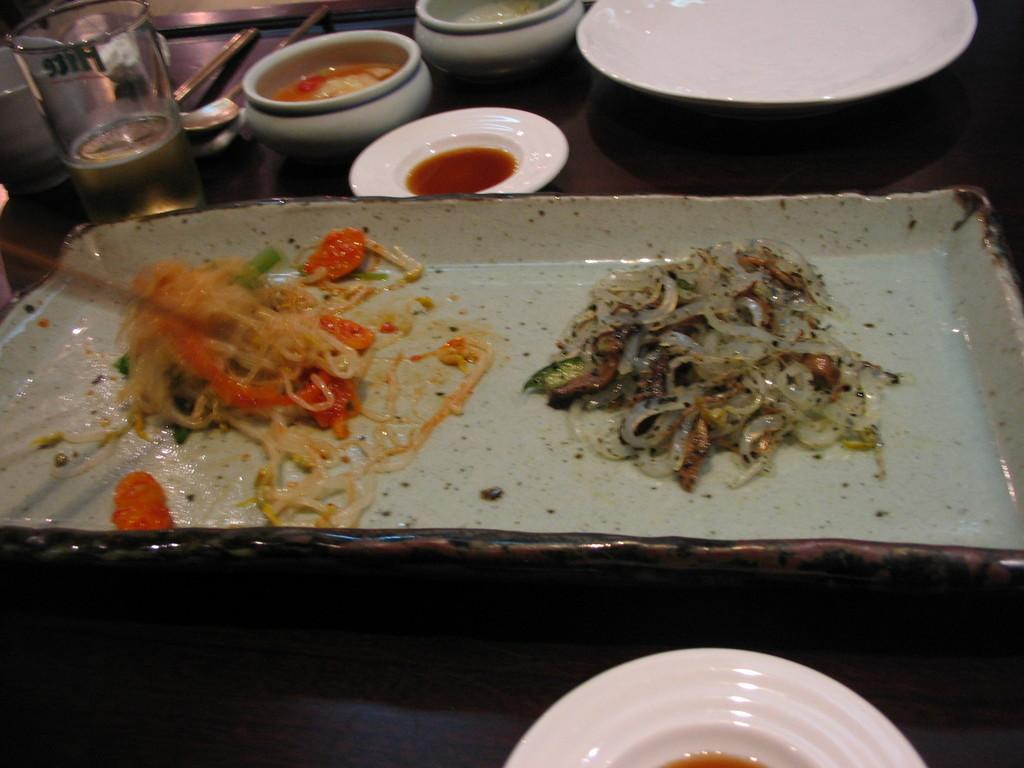What is on the plate in the image? There is food in a plate in the image. What else is on the table besides the plate? There are bowls beside the plate, a glass, spoons, and other things in the image. What might be used for drinking in the image? There is a glass in the image, which might be used for drinking. What utensils are visible in the image? Spoons are visible in the image. What is the mass of the food in the image? The mass of the food in the image cannot be determined from the image alone. --- Facts: 1. There is a person sitting on a chair in the image. 2. The person is holding a book. 3. There is a table in front of the person. 4. There is a lamp on the table. 5. The background of the image is a wall. Absurd Topics: dance, ocean, parrot Conversation: What is the person in the image doing? The person is sitting on a chair in the image. What is the person holding in the image? The person is holding a book in the image. What is on the table in front of the person? There is a lamp on the table in the image. What is the background of the image? The background of the image is a wall. Reasoning: Let's think step by step in order to produce the conversation. We start by identifying the main subject in the image, which is the person sitting on a chair. Then, we expand the conversation to include other items that are also visible, such as the book, table, lamp, and wall. Each question is designed to elicit a specific detail about the image that is known from the provided facts. Absurd Question/Answer: Can you see any parrots in the image? No, there are no parrots present in the image. 